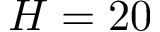<formula> <loc_0><loc_0><loc_500><loc_500>H = 2 0</formula> 